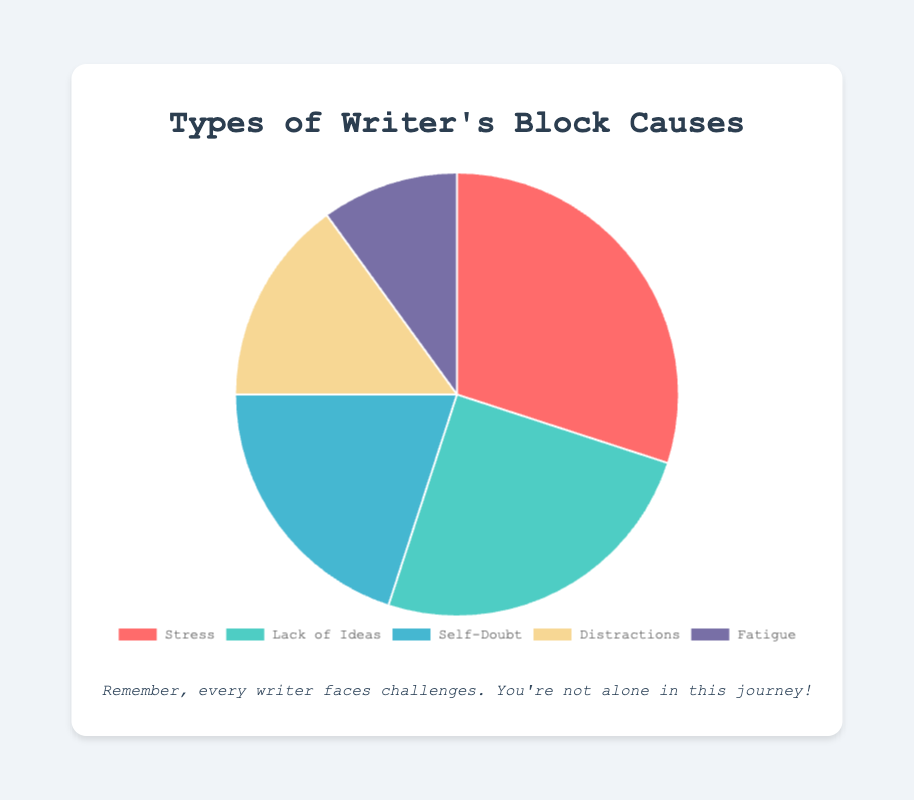what is the most common cause of writer's block reported? The most common cause is represented by the largest piece of the pie chart. The segment labeled "Stress" occupies the largest percentage, making it the most common cause.
Answer: Stress What percentage of members reported "Self-Doubt" as a cause of writer's block? Locate the segment labeled "Self-Doubt" and read the corresponding percentage. It is labeled as 20%.
Answer: 20% Which cause is more frequently reported, Distractions or Fatigue? Compare the percentage segments for "Distractions" and "Fatigue". "Distractions" is 15% and "Fatigue" is 10%. 15% is greater than 10%.
Answer: Distractions What is the combined percentage of members who reported Stress and Lack of Ideas as causes? Add the percentages of Stress (30%) and Lack of Ideas (25%). The sum is 30% + 25% = 55%.
Answer: 55% How many members reported Fatigue as their cause of writer's block? Each segment lists the members who reported it. Count the names under "Fatigue". There are 2 names: Paul Rodriguez and Linda Perez.
Answer: 2 Which cause has the least percentage reported? Find the smallest segment in the pie chart, which represents the least reported cause. It is labeled as "Fatigue" with 10%.
Answer: Fatigue How much smaller is the percentage for Self-Doubt compared to Stress? Subtract the percentage of Self-Doubt (20%) from Stress (30%). The difference is 30% - 20% = 10%.
Answer: 10% What color represents the cause "Lack of Ideas"? Look at the color coding for each segment. The segment labeled "Lack of Ideas" is represented by a green color.
Answer: Green 